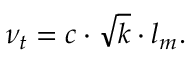Convert formula to latex. <formula><loc_0><loc_0><loc_500><loc_500>\nu _ { t } = c \cdot { \sqrt { k } } \cdot l _ { m } .</formula> 